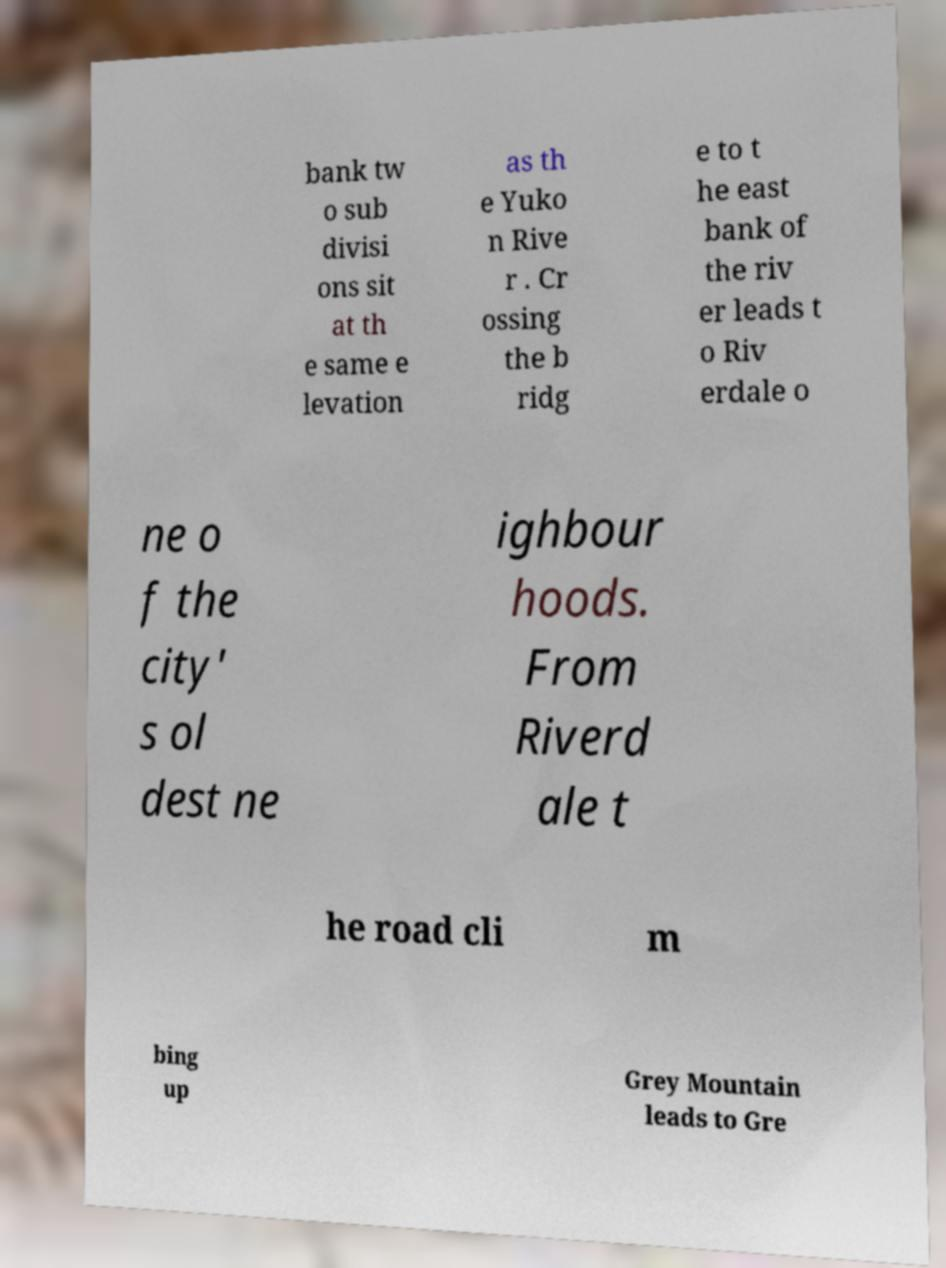For documentation purposes, I need the text within this image transcribed. Could you provide that? bank tw o sub divisi ons sit at th e same e levation as th e Yuko n Rive r . Cr ossing the b ridg e to t he east bank of the riv er leads t o Riv erdale o ne o f the city' s ol dest ne ighbour hoods. From Riverd ale t he road cli m bing up Grey Mountain leads to Gre 